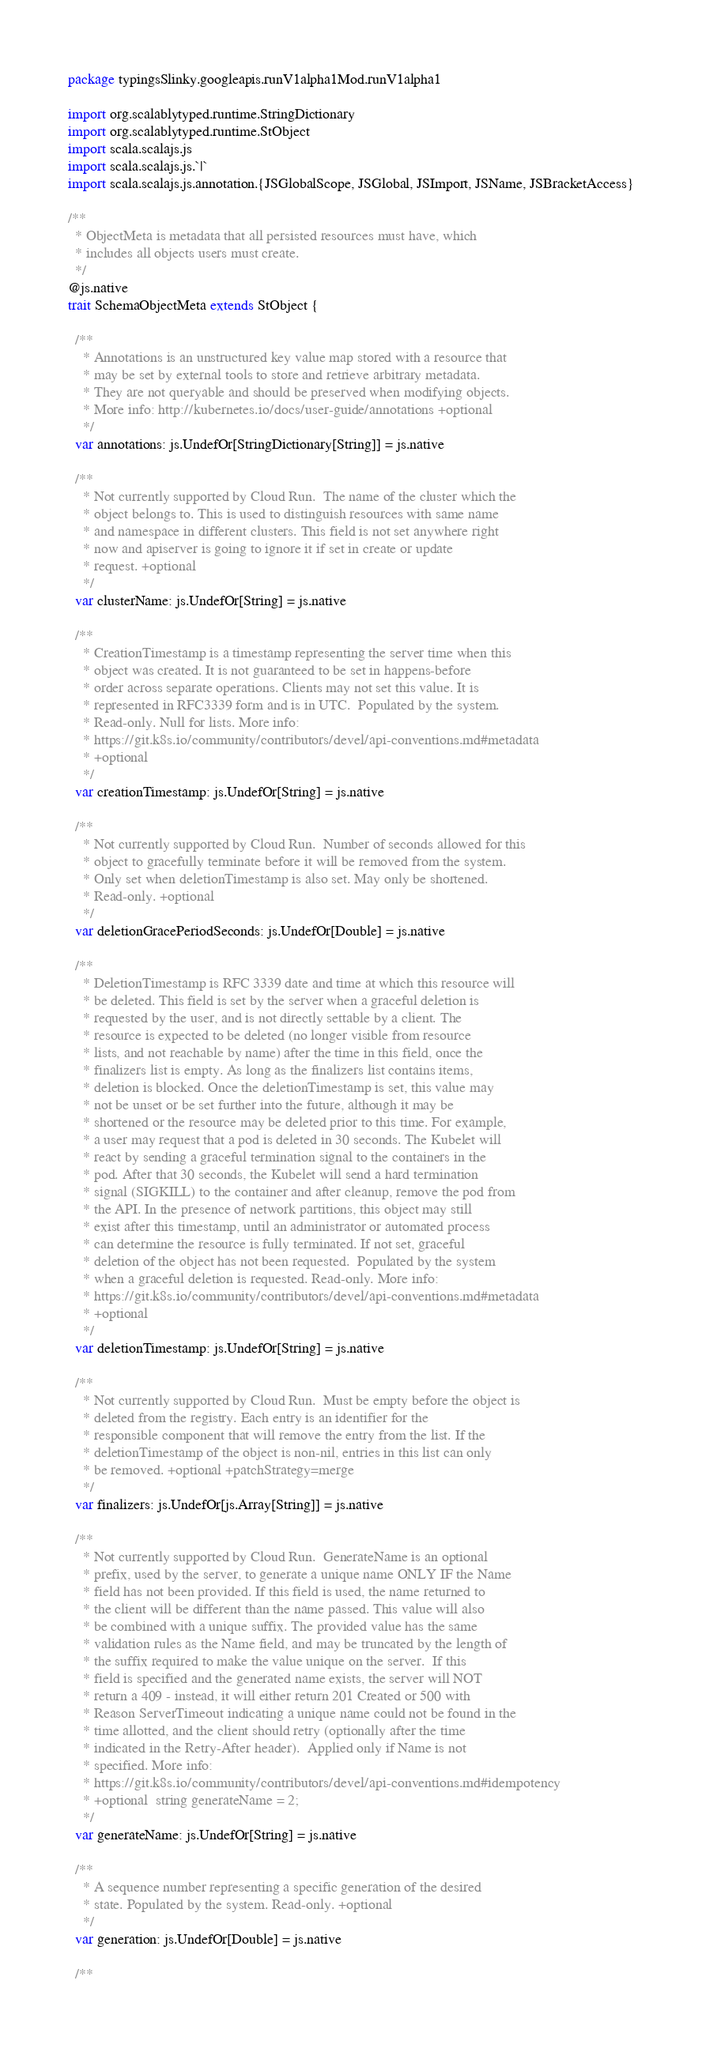Convert code to text. <code><loc_0><loc_0><loc_500><loc_500><_Scala_>package typingsSlinky.googleapis.runV1alpha1Mod.runV1alpha1

import org.scalablytyped.runtime.StringDictionary
import org.scalablytyped.runtime.StObject
import scala.scalajs.js
import scala.scalajs.js.`|`
import scala.scalajs.js.annotation.{JSGlobalScope, JSGlobal, JSImport, JSName, JSBracketAccess}

/**
  * ObjectMeta is metadata that all persisted resources must have, which
  * includes all objects users must create.
  */
@js.native
trait SchemaObjectMeta extends StObject {
  
  /**
    * Annotations is an unstructured key value map stored with a resource that
    * may be set by external tools to store and retrieve arbitrary metadata.
    * They are not queryable and should be preserved when modifying objects.
    * More info: http://kubernetes.io/docs/user-guide/annotations +optional
    */
  var annotations: js.UndefOr[StringDictionary[String]] = js.native
  
  /**
    * Not currently supported by Cloud Run.  The name of the cluster which the
    * object belongs to. This is used to distinguish resources with same name
    * and namespace in different clusters. This field is not set anywhere right
    * now and apiserver is going to ignore it if set in create or update
    * request. +optional
    */
  var clusterName: js.UndefOr[String] = js.native
  
  /**
    * CreationTimestamp is a timestamp representing the server time when this
    * object was created. It is not guaranteed to be set in happens-before
    * order across separate operations. Clients may not set this value. It is
    * represented in RFC3339 form and is in UTC.  Populated by the system.
    * Read-only. Null for lists. More info:
    * https://git.k8s.io/community/contributors/devel/api-conventions.md#metadata
    * +optional
    */
  var creationTimestamp: js.UndefOr[String] = js.native
  
  /**
    * Not currently supported by Cloud Run.  Number of seconds allowed for this
    * object to gracefully terminate before it will be removed from the system.
    * Only set when deletionTimestamp is also set. May only be shortened.
    * Read-only. +optional
    */
  var deletionGracePeriodSeconds: js.UndefOr[Double] = js.native
  
  /**
    * DeletionTimestamp is RFC 3339 date and time at which this resource will
    * be deleted. This field is set by the server when a graceful deletion is
    * requested by the user, and is not directly settable by a client. The
    * resource is expected to be deleted (no longer visible from resource
    * lists, and not reachable by name) after the time in this field, once the
    * finalizers list is empty. As long as the finalizers list contains items,
    * deletion is blocked. Once the deletionTimestamp is set, this value may
    * not be unset or be set further into the future, although it may be
    * shortened or the resource may be deleted prior to this time. For example,
    * a user may request that a pod is deleted in 30 seconds. The Kubelet will
    * react by sending a graceful termination signal to the containers in the
    * pod. After that 30 seconds, the Kubelet will send a hard termination
    * signal (SIGKILL) to the container and after cleanup, remove the pod from
    * the API. In the presence of network partitions, this object may still
    * exist after this timestamp, until an administrator or automated process
    * can determine the resource is fully terminated. If not set, graceful
    * deletion of the object has not been requested.  Populated by the system
    * when a graceful deletion is requested. Read-only. More info:
    * https://git.k8s.io/community/contributors/devel/api-conventions.md#metadata
    * +optional
    */
  var deletionTimestamp: js.UndefOr[String] = js.native
  
  /**
    * Not currently supported by Cloud Run.  Must be empty before the object is
    * deleted from the registry. Each entry is an identifier for the
    * responsible component that will remove the entry from the list. If the
    * deletionTimestamp of the object is non-nil, entries in this list can only
    * be removed. +optional +patchStrategy=merge
    */
  var finalizers: js.UndefOr[js.Array[String]] = js.native
  
  /**
    * Not currently supported by Cloud Run.  GenerateName is an optional
    * prefix, used by the server, to generate a unique name ONLY IF the Name
    * field has not been provided. If this field is used, the name returned to
    * the client will be different than the name passed. This value will also
    * be combined with a unique suffix. The provided value has the same
    * validation rules as the Name field, and may be truncated by the length of
    * the suffix required to make the value unique on the server.  If this
    * field is specified and the generated name exists, the server will NOT
    * return a 409 - instead, it will either return 201 Created or 500 with
    * Reason ServerTimeout indicating a unique name could not be found in the
    * time allotted, and the client should retry (optionally after the time
    * indicated in the Retry-After header).  Applied only if Name is not
    * specified. More info:
    * https://git.k8s.io/community/contributors/devel/api-conventions.md#idempotency
    * +optional  string generateName = 2;
    */
  var generateName: js.UndefOr[String] = js.native
  
  /**
    * A sequence number representing a specific generation of the desired
    * state. Populated by the system. Read-only. +optional
    */
  var generation: js.UndefOr[Double] = js.native
  
  /**</code> 